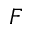Convert formula to latex. <formula><loc_0><loc_0><loc_500><loc_500>F</formula> 